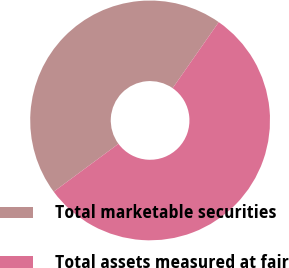Convert chart to OTSL. <chart><loc_0><loc_0><loc_500><loc_500><pie_chart><fcel>Total marketable securities<fcel>Total assets measured at fair<nl><fcel>44.83%<fcel>55.17%<nl></chart> 